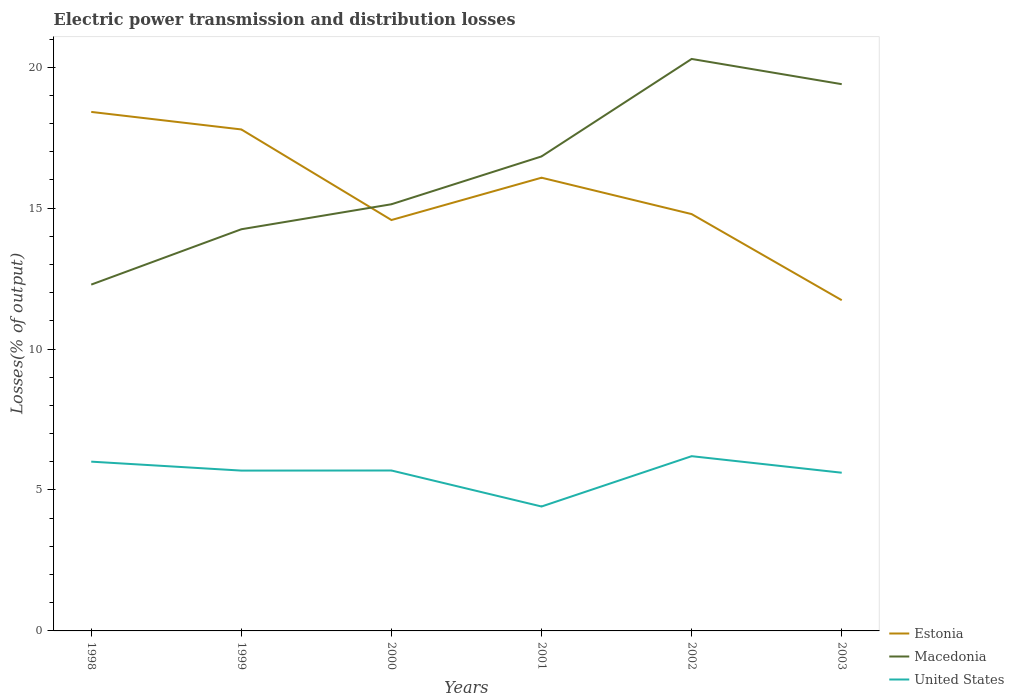Is the number of lines equal to the number of legend labels?
Keep it short and to the point. Yes. Across all years, what is the maximum electric power transmission and distribution losses in Macedonia?
Make the answer very short. 12.29. What is the total electric power transmission and distribution losses in United States in the graph?
Ensure brevity in your answer.  1.59. What is the difference between the highest and the second highest electric power transmission and distribution losses in Macedonia?
Your answer should be compact. 8.01. How many lines are there?
Your response must be concise. 3. How many years are there in the graph?
Make the answer very short. 6. Does the graph contain any zero values?
Provide a short and direct response. No. Where does the legend appear in the graph?
Provide a short and direct response. Bottom right. What is the title of the graph?
Your answer should be very brief. Electric power transmission and distribution losses. What is the label or title of the X-axis?
Provide a succinct answer. Years. What is the label or title of the Y-axis?
Your answer should be very brief. Losses(% of output). What is the Losses(% of output) of Estonia in 1998?
Keep it short and to the point. 18.41. What is the Losses(% of output) in Macedonia in 1998?
Make the answer very short. 12.29. What is the Losses(% of output) in United States in 1998?
Provide a succinct answer. 6.01. What is the Losses(% of output) in Estonia in 1999?
Provide a short and direct response. 17.79. What is the Losses(% of output) of Macedonia in 1999?
Your answer should be compact. 14.25. What is the Losses(% of output) of United States in 1999?
Your answer should be compact. 5.69. What is the Losses(% of output) of Estonia in 2000?
Offer a very short reply. 14.58. What is the Losses(% of output) in Macedonia in 2000?
Provide a succinct answer. 15.14. What is the Losses(% of output) in United States in 2000?
Offer a very short reply. 5.69. What is the Losses(% of output) in Estonia in 2001?
Offer a terse response. 16.08. What is the Losses(% of output) in Macedonia in 2001?
Provide a short and direct response. 16.83. What is the Losses(% of output) in United States in 2001?
Your response must be concise. 4.41. What is the Losses(% of output) in Estonia in 2002?
Your answer should be compact. 14.79. What is the Losses(% of output) in Macedonia in 2002?
Provide a succinct answer. 20.29. What is the Losses(% of output) in United States in 2002?
Offer a terse response. 6.2. What is the Losses(% of output) of Estonia in 2003?
Your answer should be very brief. 11.73. What is the Losses(% of output) of Macedonia in 2003?
Make the answer very short. 19.4. What is the Losses(% of output) in United States in 2003?
Your answer should be very brief. 5.61. Across all years, what is the maximum Losses(% of output) of Estonia?
Make the answer very short. 18.41. Across all years, what is the maximum Losses(% of output) of Macedonia?
Give a very brief answer. 20.29. Across all years, what is the maximum Losses(% of output) in United States?
Make the answer very short. 6.2. Across all years, what is the minimum Losses(% of output) of Estonia?
Make the answer very short. 11.73. Across all years, what is the minimum Losses(% of output) of Macedonia?
Provide a short and direct response. 12.29. Across all years, what is the minimum Losses(% of output) in United States?
Keep it short and to the point. 4.41. What is the total Losses(% of output) in Estonia in the graph?
Provide a short and direct response. 93.38. What is the total Losses(% of output) in Macedonia in the graph?
Ensure brevity in your answer.  98.2. What is the total Losses(% of output) in United States in the graph?
Provide a succinct answer. 33.61. What is the difference between the Losses(% of output) of Estonia in 1998 and that in 1999?
Ensure brevity in your answer.  0.62. What is the difference between the Losses(% of output) of Macedonia in 1998 and that in 1999?
Your answer should be compact. -1.96. What is the difference between the Losses(% of output) in United States in 1998 and that in 1999?
Offer a terse response. 0.32. What is the difference between the Losses(% of output) in Estonia in 1998 and that in 2000?
Ensure brevity in your answer.  3.84. What is the difference between the Losses(% of output) of Macedonia in 1998 and that in 2000?
Keep it short and to the point. -2.85. What is the difference between the Losses(% of output) of United States in 1998 and that in 2000?
Offer a very short reply. 0.31. What is the difference between the Losses(% of output) in Estonia in 1998 and that in 2001?
Your answer should be compact. 2.33. What is the difference between the Losses(% of output) in Macedonia in 1998 and that in 2001?
Provide a short and direct response. -4.55. What is the difference between the Losses(% of output) in United States in 1998 and that in 2001?
Your answer should be very brief. 1.59. What is the difference between the Losses(% of output) in Estonia in 1998 and that in 2002?
Provide a succinct answer. 3.62. What is the difference between the Losses(% of output) in Macedonia in 1998 and that in 2002?
Offer a very short reply. -8.01. What is the difference between the Losses(% of output) of United States in 1998 and that in 2002?
Make the answer very short. -0.19. What is the difference between the Losses(% of output) of Estonia in 1998 and that in 2003?
Your answer should be compact. 6.68. What is the difference between the Losses(% of output) in Macedonia in 1998 and that in 2003?
Offer a very short reply. -7.11. What is the difference between the Losses(% of output) in United States in 1998 and that in 2003?
Keep it short and to the point. 0.39. What is the difference between the Losses(% of output) in Estonia in 1999 and that in 2000?
Offer a very short reply. 3.21. What is the difference between the Losses(% of output) of Macedonia in 1999 and that in 2000?
Offer a very short reply. -0.89. What is the difference between the Losses(% of output) in United States in 1999 and that in 2000?
Your answer should be compact. -0. What is the difference between the Losses(% of output) of Estonia in 1999 and that in 2001?
Ensure brevity in your answer.  1.71. What is the difference between the Losses(% of output) of Macedonia in 1999 and that in 2001?
Your response must be concise. -2.58. What is the difference between the Losses(% of output) in United States in 1999 and that in 2001?
Your answer should be compact. 1.27. What is the difference between the Losses(% of output) in Estonia in 1999 and that in 2002?
Your answer should be very brief. 3. What is the difference between the Losses(% of output) of Macedonia in 1999 and that in 2002?
Offer a very short reply. -6.04. What is the difference between the Losses(% of output) in United States in 1999 and that in 2002?
Provide a succinct answer. -0.51. What is the difference between the Losses(% of output) of Estonia in 1999 and that in 2003?
Ensure brevity in your answer.  6.06. What is the difference between the Losses(% of output) in Macedonia in 1999 and that in 2003?
Offer a very short reply. -5.15. What is the difference between the Losses(% of output) of United States in 1999 and that in 2003?
Offer a very short reply. 0.08. What is the difference between the Losses(% of output) in Estonia in 2000 and that in 2001?
Ensure brevity in your answer.  -1.5. What is the difference between the Losses(% of output) in Macedonia in 2000 and that in 2001?
Offer a terse response. -1.7. What is the difference between the Losses(% of output) in United States in 2000 and that in 2001?
Ensure brevity in your answer.  1.28. What is the difference between the Losses(% of output) of Estonia in 2000 and that in 2002?
Offer a terse response. -0.21. What is the difference between the Losses(% of output) of Macedonia in 2000 and that in 2002?
Your answer should be very brief. -5.16. What is the difference between the Losses(% of output) in United States in 2000 and that in 2002?
Give a very brief answer. -0.51. What is the difference between the Losses(% of output) of Estonia in 2000 and that in 2003?
Provide a short and direct response. 2.84. What is the difference between the Losses(% of output) of Macedonia in 2000 and that in 2003?
Give a very brief answer. -4.26. What is the difference between the Losses(% of output) in United States in 2000 and that in 2003?
Your answer should be compact. 0.08. What is the difference between the Losses(% of output) in Estonia in 2001 and that in 2002?
Keep it short and to the point. 1.29. What is the difference between the Losses(% of output) of Macedonia in 2001 and that in 2002?
Your answer should be compact. -3.46. What is the difference between the Losses(% of output) in United States in 2001 and that in 2002?
Give a very brief answer. -1.79. What is the difference between the Losses(% of output) in Estonia in 2001 and that in 2003?
Your answer should be very brief. 4.35. What is the difference between the Losses(% of output) in Macedonia in 2001 and that in 2003?
Give a very brief answer. -2.56. What is the difference between the Losses(% of output) in United States in 2001 and that in 2003?
Your answer should be very brief. -1.2. What is the difference between the Losses(% of output) of Estonia in 2002 and that in 2003?
Offer a very short reply. 3.05. What is the difference between the Losses(% of output) of Macedonia in 2002 and that in 2003?
Provide a succinct answer. 0.89. What is the difference between the Losses(% of output) in United States in 2002 and that in 2003?
Your answer should be very brief. 0.59. What is the difference between the Losses(% of output) of Estonia in 1998 and the Losses(% of output) of Macedonia in 1999?
Your response must be concise. 4.16. What is the difference between the Losses(% of output) of Estonia in 1998 and the Losses(% of output) of United States in 1999?
Make the answer very short. 12.73. What is the difference between the Losses(% of output) of Macedonia in 1998 and the Losses(% of output) of United States in 1999?
Offer a terse response. 6.6. What is the difference between the Losses(% of output) of Estonia in 1998 and the Losses(% of output) of Macedonia in 2000?
Your response must be concise. 3.28. What is the difference between the Losses(% of output) in Estonia in 1998 and the Losses(% of output) in United States in 2000?
Provide a short and direct response. 12.72. What is the difference between the Losses(% of output) in Macedonia in 1998 and the Losses(% of output) in United States in 2000?
Your answer should be very brief. 6.6. What is the difference between the Losses(% of output) of Estonia in 1998 and the Losses(% of output) of Macedonia in 2001?
Keep it short and to the point. 1.58. What is the difference between the Losses(% of output) in Estonia in 1998 and the Losses(% of output) in United States in 2001?
Offer a terse response. 14. What is the difference between the Losses(% of output) in Macedonia in 1998 and the Losses(% of output) in United States in 2001?
Give a very brief answer. 7.87. What is the difference between the Losses(% of output) of Estonia in 1998 and the Losses(% of output) of Macedonia in 2002?
Your answer should be very brief. -1.88. What is the difference between the Losses(% of output) of Estonia in 1998 and the Losses(% of output) of United States in 2002?
Provide a succinct answer. 12.21. What is the difference between the Losses(% of output) of Macedonia in 1998 and the Losses(% of output) of United States in 2002?
Keep it short and to the point. 6.09. What is the difference between the Losses(% of output) in Estonia in 1998 and the Losses(% of output) in Macedonia in 2003?
Offer a terse response. -0.98. What is the difference between the Losses(% of output) in Estonia in 1998 and the Losses(% of output) in United States in 2003?
Your answer should be very brief. 12.8. What is the difference between the Losses(% of output) of Macedonia in 1998 and the Losses(% of output) of United States in 2003?
Provide a succinct answer. 6.67. What is the difference between the Losses(% of output) in Estonia in 1999 and the Losses(% of output) in Macedonia in 2000?
Provide a succinct answer. 2.65. What is the difference between the Losses(% of output) in Estonia in 1999 and the Losses(% of output) in United States in 2000?
Provide a short and direct response. 12.1. What is the difference between the Losses(% of output) in Macedonia in 1999 and the Losses(% of output) in United States in 2000?
Keep it short and to the point. 8.56. What is the difference between the Losses(% of output) in Estonia in 1999 and the Losses(% of output) in Macedonia in 2001?
Provide a short and direct response. 0.96. What is the difference between the Losses(% of output) of Estonia in 1999 and the Losses(% of output) of United States in 2001?
Your answer should be very brief. 13.38. What is the difference between the Losses(% of output) of Macedonia in 1999 and the Losses(% of output) of United States in 2001?
Provide a short and direct response. 9.84. What is the difference between the Losses(% of output) in Estonia in 1999 and the Losses(% of output) in Macedonia in 2002?
Give a very brief answer. -2.5. What is the difference between the Losses(% of output) of Estonia in 1999 and the Losses(% of output) of United States in 2002?
Ensure brevity in your answer.  11.59. What is the difference between the Losses(% of output) of Macedonia in 1999 and the Losses(% of output) of United States in 2002?
Make the answer very short. 8.05. What is the difference between the Losses(% of output) of Estonia in 1999 and the Losses(% of output) of Macedonia in 2003?
Keep it short and to the point. -1.61. What is the difference between the Losses(% of output) of Estonia in 1999 and the Losses(% of output) of United States in 2003?
Keep it short and to the point. 12.18. What is the difference between the Losses(% of output) in Macedonia in 1999 and the Losses(% of output) in United States in 2003?
Offer a terse response. 8.64. What is the difference between the Losses(% of output) in Estonia in 2000 and the Losses(% of output) in Macedonia in 2001?
Give a very brief answer. -2.26. What is the difference between the Losses(% of output) of Estonia in 2000 and the Losses(% of output) of United States in 2001?
Make the answer very short. 10.16. What is the difference between the Losses(% of output) in Macedonia in 2000 and the Losses(% of output) in United States in 2001?
Ensure brevity in your answer.  10.72. What is the difference between the Losses(% of output) in Estonia in 2000 and the Losses(% of output) in Macedonia in 2002?
Give a very brief answer. -5.71. What is the difference between the Losses(% of output) of Estonia in 2000 and the Losses(% of output) of United States in 2002?
Offer a terse response. 8.38. What is the difference between the Losses(% of output) of Macedonia in 2000 and the Losses(% of output) of United States in 2002?
Make the answer very short. 8.94. What is the difference between the Losses(% of output) of Estonia in 2000 and the Losses(% of output) of Macedonia in 2003?
Offer a very short reply. -4.82. What is the difference between the Losses(% of output) of Estonia in 2000 and the Losses(% of output) of United States in 2003?
Your answer should be very brief. 8.97. What is the difference between the Losses(% of output) of Macedonia in 2000 and the Losses(% of output) of United States in 2003?
Your answer should be very brief. 9.52. What is the difference between the Losses(% of output) in Estonia in 2001 and the Losses(% of output) in Macedonia in 2002?
Keep it short and to the point. -4.21. What is the difference between the Losses(% of output) of Estonia in 2001 and the Losses(% of output) of United States in 2002?
Your response must be concise. 9.88. What is the difference between the Losses(% of output) of Macedonia in 2001 and the Losses(% of output) of United States in 2002?
Give a very brief answer. 10.63. What is the difference between the Losses(% of output) in Estonia in 2001 and the Losses(% of output) in Macedonia in 2003?
Provide a succinct answer. -3.32. What is the difference between the Losses(% of output) in Estonia in 2001 and the Losses(% of output) in United States in 2003?
Provide a succinct answer. 10.47. What is the difference between the Losses(% of output) of Macedonia in 2001 and the Losses(% of output) of United States in 2003?
Your response must be concise. 11.22. What is the difference between the Losses(% of output) in Estonia in 2002 and the Losses(% of output) in Macedonia in 2003?
Your answer should be very brief. -4.61. What is the difference between the Losses(% of output) of Estonia in 2002 and the Losses(% of output) of United States in 2003?
Ensure brevity in your answer.  9.18. What is the difference between the Losses(% of output) in Macedonia in 2002 and the Losses(% of output) in United States in 2003?
Keep it short and to the point. 14.68. What is the average Losses(% of output) in Estonia per year?
Make the answer very short. 15.56. What is the average Losses(% of output) in Macedonia per year?
Ensure brevity in your answer.  16.37. What is the average Losses(% of output) of United States per year?
Your response must be concise. 5.6. In the year 1998, what is the difference between the Losses(% of output) in Estonia and Losses(% of output) in Macedonia?
Your response must be concise. 6.13. In the year 1998, what is the difference between the Losses(% of output) in Estonia and Losses(% of output) in United States?
Keep it short and to the point. 12.41. In the year 1998, what is the difference between the Losses(% of output) in Macedonia and Losses(% of output) in United States?
Your response must be concise. 6.28. In the year 1999, what is the difference between the Losses(% of output) in Estonia and Losses(% of output) in Macedonia?
Your answer should be very brief. 3.54. In the year 1999, what is the difference between the Losses(% of output) of Estonia and Losses(% of output) of United States?
Offer a very short reply. 12.1. In the year 1999, what is the difference between the Losses(% of output) in Macedonia and Losses(% of output) in United States?
Your response must be concise. 8.56. In the year 2000, what is the difference between the Losses(% of output) of Estonia and Losses(% of output) of Macedonia?
Your answer should be very brief. -0.56. In the year 2000, what is the difference between the Losses(% of output) in Estonia and Losses(% of output) in United States?
Ensure brevity in your answer.  8.89. In the year 2000, what is the difference between the Losses(% of output) of Macedonia and Losses(% of output) of United States?
Your answer should be compact. 9.45. In the year 2001, what is the difference between the Losses(% of output) in Estonia and Losses(% of output) in Macedonia?
Offer a very short reply. -0.76. In the year 2001, what is the difference between the Losses(% of output) in Estonia and Losses(% of output) in United States?
Provide a short and direct response. 11.66. In the year 2001, what is the difference between the Losses(% of output) in Macedonia and Losses(% of output) in United States?
Offer a very short reply. 12.42. In the year 2002, what is the difference between the Losses(% of output) of Estonia and Losses(% of output) of Macedonia?
Ensure brevity in your answer.  -5.5. In the year 2002, what is the difference between the Losses(% of output) of Estonia and Losses(% of output) of United States?
Provide a succinct answer. 8.59. In the year 2002, what is the difference between the Losses(% of output) in Macedonia and Losses(% of output) in United States?
Your answer should be very brief. 14.09. In the year 2003, what is the difference between the Losses(% of output) in Estonia and Losses(% of output) in Macedonia?
Offer a very short reply. -7.66. In the year 2003, what is the difference between the Losses(% of output) of Estonia and Losses(% of output) of United States?
Keep it short and to the point. 6.12. In the year 2003, what is the difference between the Losses(% of output) in Macedonia and Losses(% of output) in United States?
Your answer should be very brief. 13.78. What is the ratio of the Losses(% of output) in Estonia in 1998 to that in 1999?
Your response must be concise. 1.03. What is the ratio of the Losses(% of output) of Macedonia in 1998 to that in 1999?
Offer a terse response. 0.86. What is the ratio of the Losses(% of output) of United States in 1998 to that in 1999?
Provide a short and direct response. 1.06. What is the ratio of the Losses(% of output) in Estonia in 1998 to that in 2000?
Keep it short and to the point. 1.26. What is the ratio of the Losses(% of output) of Macedonia in 1998 to that in 2000?
Keep it short and to the point. 0.81. What is the ratio of the Losses(% of output) in United States in 1998 to that in 2000?
Offer a terse response. 1.06. What is the ratio of the Losses(% of output) of Estonia in 1998 to that in 2001?
Offer a terse response. 1.15. What is the ratio of the Losses(% of output) of Macedonia in 1998 to that in 2001?
Your response must be concise. 0.73. What is the ratio of the Losses(% of output) of United States in 1998 to that in 2001?
Offer a very short reply. 1.36. What is the ratio of the Losses(% of output) of Estonia in 1998 to that in 2002?
Your response must be concise. 1.25. What is the ratio of the Losses(% of output) in Macedonia in 1998 to that in 2002?
Your answer should be very brief. 0.61. What is the ratio of the Losses(% of output) in United States in 1998 to that in 2002?
Your response must be concise. 0.97. What is the ratio of the Losses(% of output) of Estonia in 1998 to that in 2003?
Your response must be concise. 1.57. What is the ratio of the Losses(% of output) in Macedonia in 1998 to that in 2003?
Give a very brief answer. 0.63. What is the ratio of the Losses(% of output) of United States in 1998 to that in 2003?
Provide a short and direct response. 1.07. What is the ratio of the Losses(% of output) in Estonia in 1999 to that in 2000?
Your answer should be compact. 1.22. What is the ratio of the Losses(% of output) of Macedonia in 1999 to that in 2000?
Make the answer very short. 0.94. What is the ratio of the Losses(% of output) of United States in 1999 to that in 2000?
Your response must be concise. 1. What is the ratio of the Losses(% of output) of Estonia in 1999 to that in 2001?
Offer a terse response. 1.11. What is the ratio of the Losses(% of output) in Macedonia in 1999 to that in 2001?
Ensure brevity in your answer.  0.85. What is the ratio of the Losses(% of output) of United States in 1999 to that in 2001?
Keep it short and to the point. 1.29. What is the ratio of the Losses(% of output) of Estonia in 1999 to that in 2002?
Provide a short and direct response. 1.2. What is the ratio of the Losses(% of output) of Macedonia in 1999 to that in 2002?
Your response must be concise. 0.7. What is the ratio of the Losses(% of output) of United States in 1999 to that in 2002?
Make the answer very short. 0.92. What is the ratio of the Losses(% of output) in Estonia in 1999 to that in 2003?
Your answer should be compact. 1.52. What is the ratio of the Losses(% of output) in Macedonia in 1999 to that in 2003?
Your answer should be compact. 0.73. What is the ratio of the Losses(% of output) of United States in 1999 to that in 2003?
Offer a terse response. 1.01. What is the ratio of the Losses(% of output) of Estonia in 2000 to that in 2001?
Offer a terse response. 0.91. What is the ratio of the Losses(% of output) of Macedonia in 2000 to that in 2001?
Your answer should be very brief. 0.9. What is the ratio of the Losses(% of output) of United States in 2000 to that in 2001?
Make the answer very short. 1.29. What is the ratio of the Losses(% of output) in Estonia in 2000 to that in 2002?
Your response must be concise. 0.99. What is the ratio of the Losses(% of output) of Macedonia in 2000 to that in 2002?
Offer a very short reply. 0.75. What is the ratio of the Losses(% of output) in United States in 2000 to that in 2002?
Provide a succinct answer. 0.92. What is the ratio of the Losses(% of output) in Estonia in 2000 to that in 2003?
Your response must be concise. 1.24. What is the ratio of the Losses(% of output) of Macedonia in 2000 to that in 2003?
Your answer should be compact. 0.78. What is the ratio of the Losses(% of output) in United States in 2000 to that in 2003?
Your response must be concise. 1.01. What is the ratio of the Losses(% of output) in Estonia in 2001 to that in 2002?
Make the answer very short. 1.09. What is the ratio of the Losses(% of output) of Macedonia in 2001 to that in 2002?
Offer a terse response. 0.83. What is the ratio of the Losses(% of output) in United States in 2001 to that in 2002?
Give a very brief answer. 0.71. What is the ratio of the Losses(% of output) of Estonia in 2001 to that in 2003?
Give a very brief answer. 1.37. What is the ratio of the Losses(% of output) in Macedonia in 2001 to that in 2003?
Provide a succinct answer. 0.87. What is the ratio of the Losses(% of output) of United States in 2001 to that in 2003?
Offer a terse response. 0.79. What is the ratio of the Losses(% of output) in Estonia in 2002 to that in 2003?
Ensure brevity in your answer.  1.26. What is the ratio of the Losses(% of output) in Macedonia in 2002 to that in 2003?
Provide a succinct answer. 1.05. What is the ratio of the Losses(% of output) in United States in 2002 to that in 2003?
Offer a very short reply. 1.1. What is the difference between the highest and the second highest Losses(% of output) in Estonia?
Ensure brevity in your answer.  0.62. What is the difference between the highest and the second highest Losses(% of output) of Macedonia?
Make the answer very short. 0.89. What is the difference between the highest and the second highest Losses(% of output) of United States?
Make the answer very short. 0.19. What is the difference between the highest and the lowest Losses(% of output) in Estonia?
Keep it short and to the point. 6.68. What is the difference between the highest and the lowest Losses(% of output) in Macedonia?
Keep it short and to the point. 8.01. What is the difference between the highest and the lowest Losses(% of output) of United States?
Make the answer very short. 1.79. 